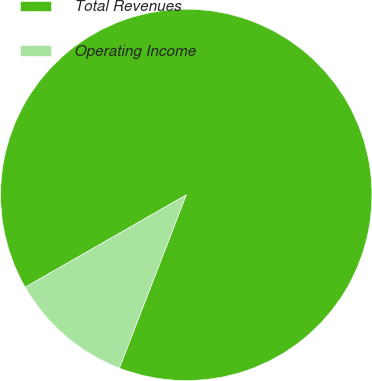<chart> <loc_0><loc_0><loc_500><loc_500><pie_chart><fcel>Total Revenues<fcel>Operating Income<nl><fcel>89.15%<fcel>10.85%<nl></chart> 